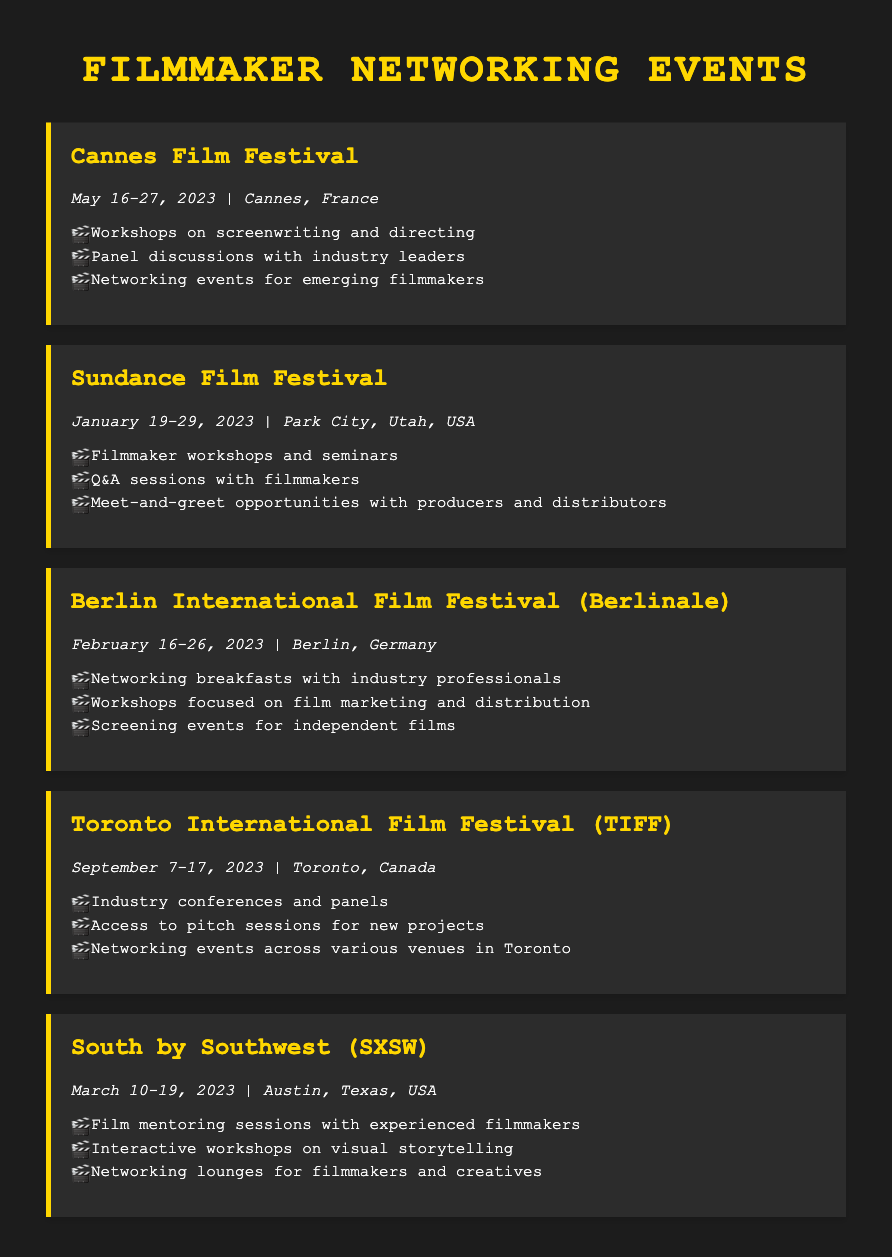what is the location of the Cannes Film Festival? The document specifies that the Cannes Film Festival is held in Cannes, France.
Answer: Cannes, France when does the Toronto International Film Festival take place? The document states that the Toronto International Film Festival occurs from September 7 to 17, 2023.
Answer: September 7-17, 2023 which event offers workshops on screenwriting and directing? The Cannes Film Festival is mentioned as providing workshops on screenwriting and directing.
Answer: Cannes Film Festival what types of opportunities are available at the Sundance Film Festival? The Sundance Film Festival offers workshops, Q&A sessions, and meet-and-greet opportunities with producers and distributors.
Answer: Workshops, Q&A sessions, meet-and-greet opportunities how many networking events for emerging filmmakers are listed for the Cannes Film Festival? The document mentions one networking event for emerging filmmakers at the Cannes Film Festival.
Answer: 1 which festival occurs in February 2023? According to the document, the Berlin International Film Festival (Berlinale) takes place in February 2023.
Answer: Berlin International Film Festival (Berlinale) what is a feature of the South by Southwest event? The South by Southwest event includes film mentoring sessions with experienced filmmakers.
Answer: Film mentoring sessions list one opportunity at the Toronto International Film Festival. The document states that one opportunity is access to pitch sessions for new projects.
Answer: Access to pitch sessions for new projects 